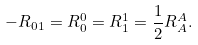Convert formula to latex. <formula><loc_0><loc_0><loc_500><loc_500>- R _ { 0 1 } = R _ { 0 } ^ { 0 } = R _ { 1 } ^ { 1 } = \frac { 1 } { 2 } R _ { A } ^ { A } .</formula> 